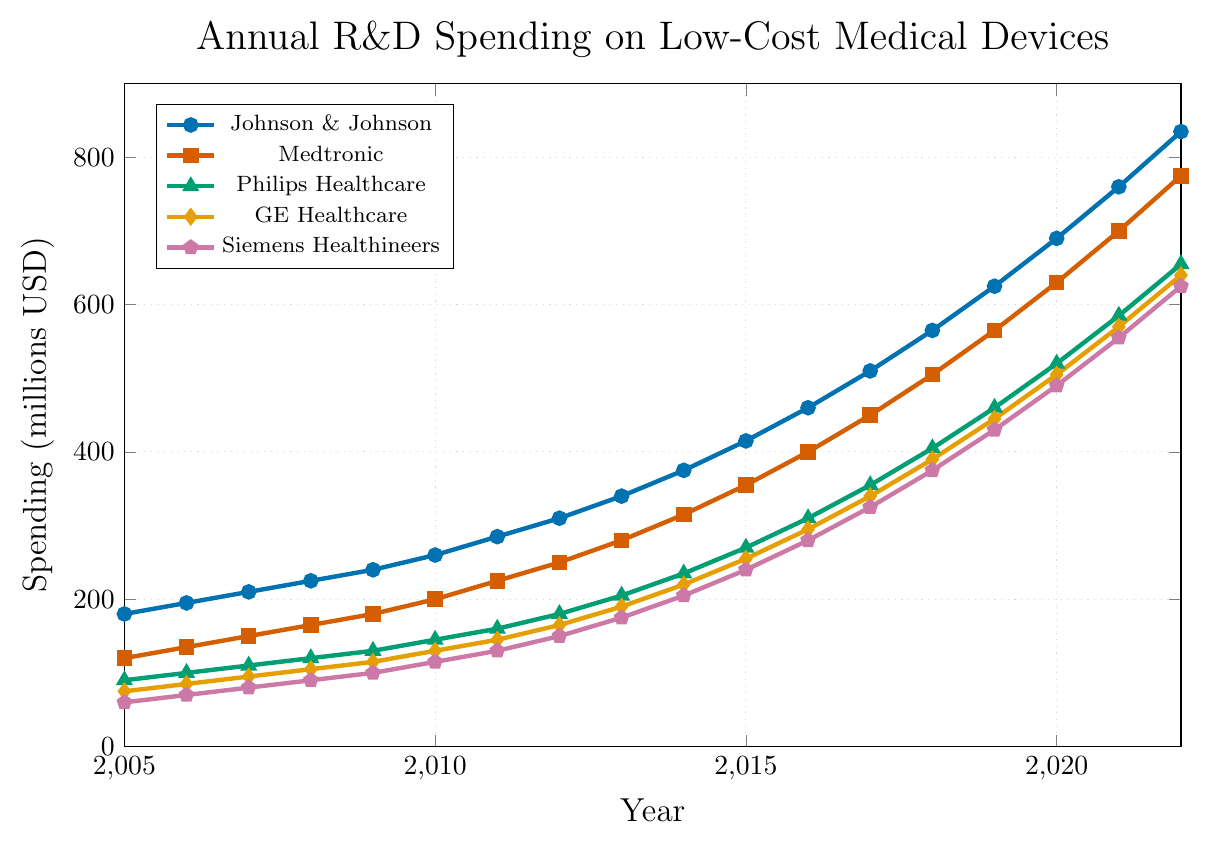Which company had the highest R&D spending in 2022? To find the company with the highest spending in 2022, compare the data points associated with each company for that year. Johnson & Johnson spent 835 million USD, Medtronic spent 775 million USD, Philips Healthcare spent 655 million USD, GE Healthcare spent 640 million USD, and Siemens Healthineers spent 625 million USD. Therefore, Johnson & Johnson had the highest spending.
Answer: Johnson & Johnson Which company showed the fastest growth in R&D spending from 2005 to 2022? To determine the fastest growth, first calculate the difference in spending for each company between 2005 and 2022. Johnson & Johnson: 835-180 = 655 million USD, Medtronic: 775-120 = 655 million USD, Philips Healthcare: 655-90 = 565 million USD, GE Healthcare: 640-75 = 565 million USD, Siemens Healthineers: 625-60 = 565 million USD. Both Johnson & Johnson and Medtronic showed the fastest growth with an increase of 655 million USD.
Answer: Johnson & Johnson, Medtronic What is the average R&D spending by Philips Healthcare across the years presented? To find the average, sum the annual spending values for Philips Healthcare and then divide by the number of years. Sum: 90+100+110+120+130+145+160+180+205+235+270+310+355+405+460+520+585+655 = 5,050 million USD. Number of years: 18. Average: 5050 / 18 = 280.56 million USD.
Answer: 280.56 million USD Which year saw the steepest increase in R&D spending for GE Healthcare? Calculate the year-over-year increase by subtracting the previous year's spending from the current year's spending. The steepest increase will be the highest value. 2006-2005: 85-75 = 10, 2007-2006: 95-85 = 10, 2008-2007: 105-95 = 10, 2009-2008: 115-105 = 10, 2010-2009: 130-115 = 15, 2011-2010: 145-130 = 15, 2012-2011: 165-145 = 20, 2013-2012: 190-165 = 25, 2014-2013: 220-190 = 30, 2015-2014: 255-220 = 35, 2016-2015: 295-255 = 40, 2017-2016: 340-295 = 45, 2018-2017: 390-340 = 50, 2019-2018: 445-390 = 55, 2020-2019: 505-445 = 60, 2021-2020: 570-505 = 65, 2022-2021: 640-570 = 70. The steepest increase was from 2021 to 2022 with an increase of 70 million USD.
Answer: 2021 to 2022 By how much did Siemens Healthineers’ R&D spending increase on average each year? Calculate the total increase by subtracting the initial year's spending from the final year's spending, then divide by the number of years to find the average annual increase. Total increase: 625-60 = 565 million USD. Number of years: 2022-2005 = 17. Average annual increase: 565 / 17 = 33.24 million USD.
Answer: 33.24 million USD Which two companies had the closest R&D spending values in 2018? Compare the 2018 spending values of each company: Johnson & Johnson: 565 million USD, Medtronic: 505 million USD, Philips Healthcare: 405 million USD, GE Healthcare: 390 million USD, Siemens Healthineers: 375 million USD. The closest values are for GE Healthcare and Siemens Healthineers, differing by 15 million USD.
Answer: GE Healthcare and Siemens Healthineers In which year did Johnson & Johnson surpass 500 million USD in R&D spending? Look at the spending values for Johnson & Johnson over the years. In 2017, Johnson & Johnson spent 510 million USD, which is the first time it surpasses 500 million USD.
Answer: 2017 Combine the R&D spending of all companies in 2015. What is the total? Sum the spending values of all companies for the year 2015. Johnson & Johnson: 415 million USD, Medtronic: 355 million USD, Philips Healthcare: 270 million USD, GE Healthcare: 255 million USD, Siemens Healthineers: 240 million USD. Total: 415+355+270+255+240 = 1,535 million USD.
Answer: 1,535 million USD Which color represents Philips Healthcare in the chart? Philips Healthcare is represented by the green line with triangle markers, one of the five distinct colors used in the chart.
Answer: Green 